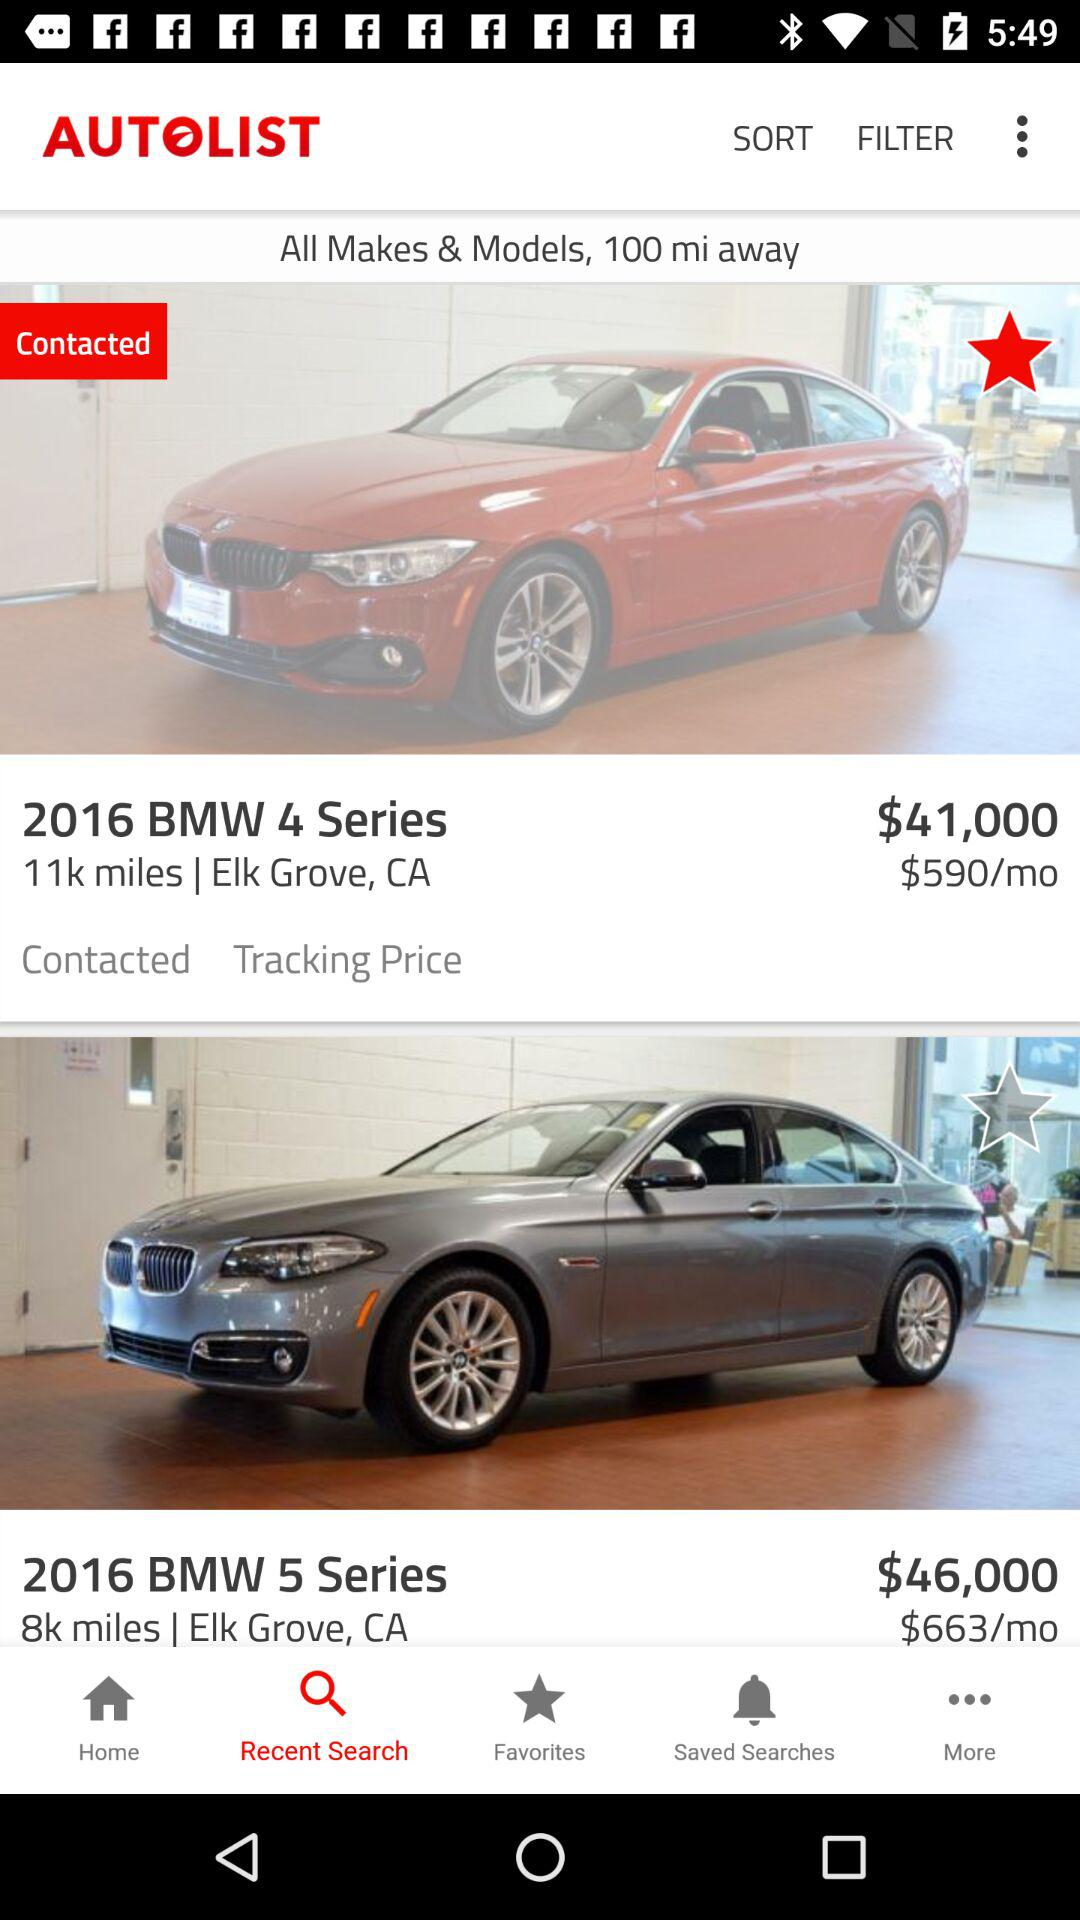How much more expensive is the BMW 5 Series than the BMW 4 Series?
Answer the question using a single word or phrase. $5,000 